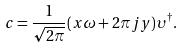Convert formula to latex. <formula><loc_0><loc_0><loc_500><loc_500>c = \frac { 1 } { \sqrt { 2 \pi } } ( x \omega + 2 \pi j y ) \upsilon ^ { \dagger } .</formula> 